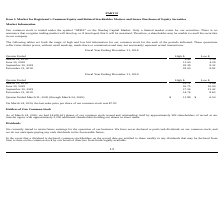According to Optimizerx Corporation's financial document, What is the Company’s trading symbol?  According to the financial document, OPRX. The relevant text states: "tion Our common stock is traded under the symbol “OPRX” on the Nasdaq Capital Market. Only a limited market exists for our securities. There is no assuran..." Also, What does the table show us? the range of high and low bid information for our common stock for the each of the periods indicated. The document states: "es in our company. The following tables set forth the range of high and low bid information for our common stock for the each of the periods indicated..." Also, What was the last sales price per share of the Company’s common stock on March 24, 2020? According to the financial document, $7.93. The relevant text states: "last sales price per share of our common stock was $7.93 Holders of Our Common Stock As of March 24, 2020, we had 14,605,611 shares of our common stock issue..." Also, can you calculate: What is the average of high bids throughout 2018?  To answer this question, I need to perform calculations using the financial data. The calculation is: (4.98+11.00+18.39+18.00)/4 , which equals 13.09. This is based on the information: "June 30, 2018 11.00 4.29 March 31, 2018 4.98 3.36 September 30, 2018 18.39 9.32 December 31, 2018 18.00 8.92..." The key data points involved are: 11.00, 18.00, 18.39. Additionally, Which quarter had the greatest low bid on the Company’s common stock? According to the financial document, September 30, 2018. The relevant text states: "September 30, 2018 18.39 9.32..." Also, can you calculate: What is the ratio of the last sales price of the Company’s common stock on March 24, 2020, to the low bid on September 30, 2018? Based on the calculation: 7.93/9.32 , the result is 0.85. This is based on the information: "September 30, 2018 18.39 9.32 st sales price per share of our common stock was $7.93 Holders of Our Common Stock As of March 24, 2020, we had 14,605,611 shares of our common stock issu..." The key data points involved are: 7.93, 9.32. 